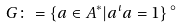<formula> <loc_0><loc_0><loc_500><loc_500>G \colon = \{ a \in A ^ { * } | a ^ { \iota } a = 1 \} \, ^ { \circ }</formula> 